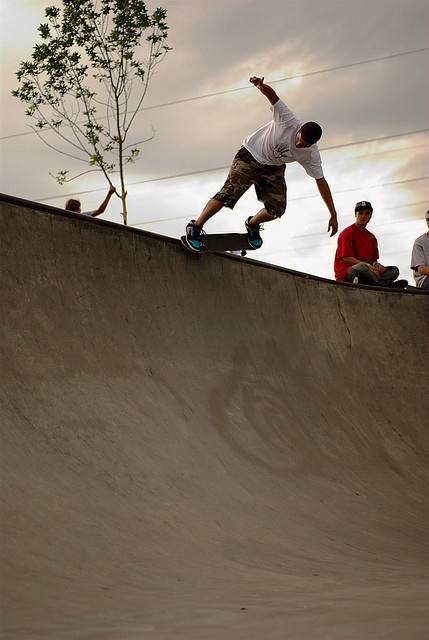Describe the objects in this image and their specific colors. I can see people in lightgray, black, gray, white, and darkgray tones, people in lightgray, black, maroon, and gray tones, skateboard in lightgray, black, gray, darkgray, and maroon tones, people in lightgray, gray, black, and maroon tones, and people in lightgray, black, maroon, olive, and gray tones in this image. 